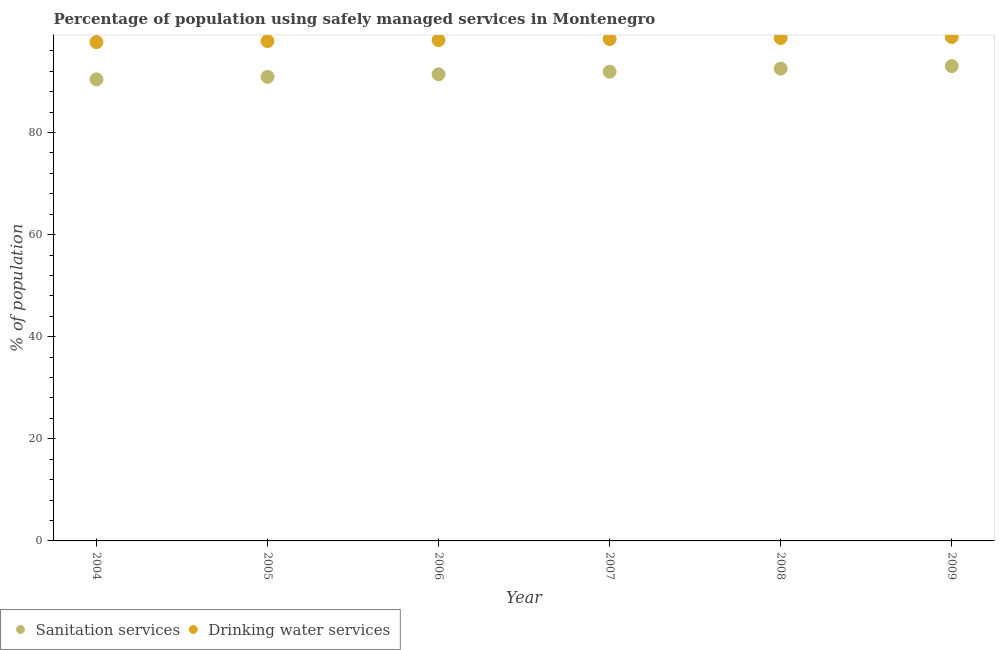How many different coloured dotlines are there?
Keep it short and to the point. 2. Is the number of dotlines equal to the number of legend labels?
Your response must be concise. Yes. What is the percentage of population who used sanitation services in 2009?
Your response must be concise. 93. Across all years, what is the maximum percentage of population who used drinking water services?
Your answer should be compact. 98.7. Across all years, what is the minimum percentage of population who used drinking water services?
Provide a succinct answer. 97.7. In which year was the percentage of population who used sanitation services maximum?
Keep it short and to the point. 2009. In which year was the percentage of population who used drinking water services minimum?
Offer a terse response. 2004. What is the total percentage of population who used drinking water services in the graph?
Offer a terse response. 589.2. What is the difference between the percentage of population who used sanitation services in 2004 and that in 2009?
Your answer should be very brief. -2.6. What is the difference between the percentage of population who used drinking water services in 2008 and the percentage of population who used sanitation services in 2004?
Offer a terse response. 8.1. What is the average percentage of population who used sanitation services per year?
Offer a very short reply. 91.68. In how many years, is the percentage of population who used drinking water services greater than 68 %?
Provide a short and direct response. 6. What is the ratio of the percentage of population who used drinking water services in 2004 to that in 2008?
Make the answer very short. 0.99. Is the percentage of population who used sanitation services in 2004 less than that in 2006?
Your response must be concise. Yes. What is the difference between the highest and the second highest percentage of population who used sanitation services?
Make the answer very short. 0.5. Is the sum of the percentage of population who used drinking water services in 2007 and 2009 greater than the maximum percentage of population who used sanitation services across all years?
Provide a succinct answer. Yes. Does the percentage of population who used drinking water services monotonically increase over the years?
Your answer should be very brief. Yes. Is the percentage of population who used drinking water services strictly greater than the percentage of population who used sanitation services over the years?
Your answer should be very brief. Yes. Is the percentage of population who used sanitation services strictly less than the percentage of population who used drinking water services over the years?
Ensure brevity in your answer.  Yes. How many years are there in the graph?
Your answer should be very brief. 6. Are the values on the major ticks of Y-axis written in scientific E-notation?
Your answer should be compact. No. Does the graph contain any zero values?
Offer a very short reply. No. Does the graph contain grids?
Your answer should be compact. No. Where does the legend appear in the graph?
Provide a short and direct response. Bottom left. How many legend labels are there?
Give a very brief answer. 2. How are the legend labels stacked?
Provide a short and direct response. Horizontal. What is the title of the graph?
Give a very brief answer. Percentage of population using safely managed services in Montenegro. What is the label or title of the X-axis?
Provide a succinct answer. Year. What is the label or title of the Y-axis?
Offer a very short reply. % of population. What is the % of population of Sanitation services in 2004?
Offer a very short reply. 90.4. What is the % of population of Drinking water services in 2004?
Your answer should be compact. 97.7. What is the % of population in Sanitation services in 2005?
Your answer should be compact. 90.9. What is the % of population in Drinking water services in 2005?
Provide a short and direct response. 97.9. What is the % of population in Sanitation services in 2006?
Your response must be concise. 91.4. What is the % of population of Drinking water services in 2006?
Offer a very short reply. 98.1. What is the % of population of Sanitation services in 2007?
Provide a short and direct response. 91.9. What is the % of population of Drinking water services in 2007?
Provide a succinct answer. 98.3. What is the % of population of Sanitation services in 2008?
Give a very brief answer. 92.5. What is the % of population of Drinking water services in 2008?
Your answer should be compact. 98.5. What is the % of population of Sanitation services in 2009?
Your response must be concise. 93. What is the % of population of Drinking water services in 2009?
Your answer should be very brief. 98.7. Across all years, what is the maximum % of population in Sanitation services?
Ensure brevity in your answer.  93. Across all years, what is the maximum % of population of Drinking water services?
Keep it short and to the point. 98.7. Across all years, what is the minimum % of population in Sanitation services?
Offer a very short reply. 90.4. Across all years, what is the minimum % of population in Drinking water services?
Provide a short and direct response. 97.7. What is the total % of population in Sanitation services in the graph?
Offer a very short reply. 550.1. What is the total % of population of Drinking water services in the graph?
Provide a succinct answer. 589.2. What is the difference between the % of population in Drinking water services in 2004 and that in 2005?
Give a very brief answer. -0.2. What is the difference between the % of population in Sanitation services in 2004 and that in 2006?
Offer a terse response. -1. What is the difference between the % of population of Drinking water services in 2004 and that in 2007?
Give a very brief answer. -0.6. What is the difference between the % of population in Sanitation services in 2004 and that in 2008?
Make the answer very short. -2.1. What is the difference between the % of population in Drinking water services in 2004 and that in 2008?
Offer a terse response. -0.8. What is the difference between the % of population in Sanitation services in 2004 and that in 2009?
Make the answer very short. -2.6. What is the difference between the % of population in Drinking water services in 2005 and that in 2006?
Keep it short and to the point. -0.2. What is the difference between the % of population of Sanitation services in 2005 and that in 2007?
Give a very brief answer. -1. What is the difference between the % of population in Drinking water services in 2005 and that in 2007?
Give a very brief answer. -0.4. What is the difference between the % of population of Sanitation services in 2005 and that in 2009?
Keep it short and to the point. -2.1. What is the difference between the % of population of Sanitation services in 2006 and that in 2008?
Provide a succinct answer. -1.1. What is the difference between the % of population in Drinking water services in 2006 and that in 2008?
Provide a succinct answer. -0.4. What is the difference between the % of population in Drinking water services in 2006 and that in 2009?
Offer a very short reply. -0.6. What is the difference between the % of population in Drinking water services in 2007 and that in 2008?
Keep it short and to the point. -0.2. What is the difference between the % of population in Drinking water services in 2007 and that in 2009?
Provide a succinct answer. -0.4. What is the difference between the % of population in Sanitation services in 2008 and that in 2009?
Keep it short and to the point. -0.5. What is the difference between the % of population of Sanitation services in 2004 and the % of population of Drinking water services in 2005?
Offer a very short reply. -7.5. What is the difference between the % of population of Sanitation services in 2004 and the % of population of Drinking water services in 2006?
Provide a short and direct response. -7.7. What is the difference between the % of population in Sanitation services in 2004 and the % of population in Drinking water services in 2007?
Give a very brief answer. -7.9. What is the difference between the % of population in Sanitation services in 2004 and the % of population in Drinking water services in 2008?
Your response must be concise. -8.1. What is the difference between the % of population in Sanitation services in 2005 and the % of population in Drinking water services in 2008?
Provide a succinct answer. -7.6. What is the difference between the % of population in Sanitation services in 2005 and the % of population in Drinking water services in 2009?
Your answer should be very brief. -7.8. What is the difference between the % of population of Sanitation services in 2006 and the % of population of Drinking water services in 2007?
Offer a very short reply. -6.9. What is the difference between the % of population in Sanitation services in 2007 and the % of population in Drinking water services in 2008?
Make the answer very short. -6.6. What is the difference between the % of population in Sanitation services in 2007 and the % of population in Drinking water services in 2009?
Keep it short and to the point. -6.8. What is the average % of population of Sanitation services per year?
Ensure brevity in your answer.  91.68. What is the average % of population of Drinking water services per year?
Give a very brief answer. 98.2. In the year 2004, what is the difference between the % of population in Sanitation services and % of population in Drinking water services?
Give a very brief answer. -7.3. In the year 2007, what is the difference between the % of population in Sanitation services and % of population in Drinking water services?
Give a very brief answer. -6.4. In the year 2008, what is the difference between the % of population in Sanitation services and % of population in Drinking water services?
Your answer should be compact. -6. In the year 2009, what is the difference between the % of population of Sanitation services and % of population of Drinking water services?
Make the answer very short. -5.7. What is the ratio of the % of population of Drinking water services in 2004 to that in 2005?
Keep it short and to the point. 1. What is the ratio of the % of population in Sanitation services in 2004 to that in 2006?
Provide a succinct answer. 0.99. What is the ratio of the % of population of Sanitation services in 2004 to that in 2007?
Your answer should be very brief. 0.98. What is the ratio of the % of population of Sanitation services in 2004 to that in 2008?
Ensure brevity in your answer.  0.98. What is the ratio of the % of population in Drinking water services in 2004 to that in 2008?
Give a very brief answer. 0.99. What is the ratio of the % of population in Sanitation services in 2004 to that in 2009?
Give a very brief answer. 0.97. What is the ratio of the % of population of Drinking water services in 2005 to that in 2006?
Offer a terse response. 1. What is the ratio of the % of population in Drinking water services in 2005 to that in 2007?
Offer a terse response. 1. What is the ratio of the % of population in Sanitation services in 2005 to that in 2008?
Provide a succinct answer. 0.98. What is the ratio of the % of population in Sanitation services in 2005 to that in 2009?
Give a very brief answer. 0.98. What is the ratio of the % of population in Drinking water services in 2005 to that in 2009?
Your response must be concise. 0.99. What is the ratio of the % of population in Sanitation services in 2006 to that in 2008?
Your answer should be very brief. 0.99. What is the ratio of the % of population in Drinking water services in 2006 to that in 2008?
Ensure brevity in your answer.  1. What is the ratio of the % of population in Sanitation services in 2006 to that in 2009?
Ensure brevity in your answer.  0.98. What is the ratio of the % of population in Drinking water services in 2006 to that in 2009?
Your response must be concise. 0.99. What is the ratio of the % of population in Drinking water services in 2007 to that in 2008?
Keep it short and to the point. 1. What is the ratio of the % of population of Sanitation services in 2008 to that in 2009?
Your answer should be compact. 0.99. What is the difference between the highest and the lowest % of population in Sanitation services?
Keep it short and to the point. 2.6. What is the difference between the highest and the lowest % of population in Drinking water services?
Ensure brevity in your answer.  1. 